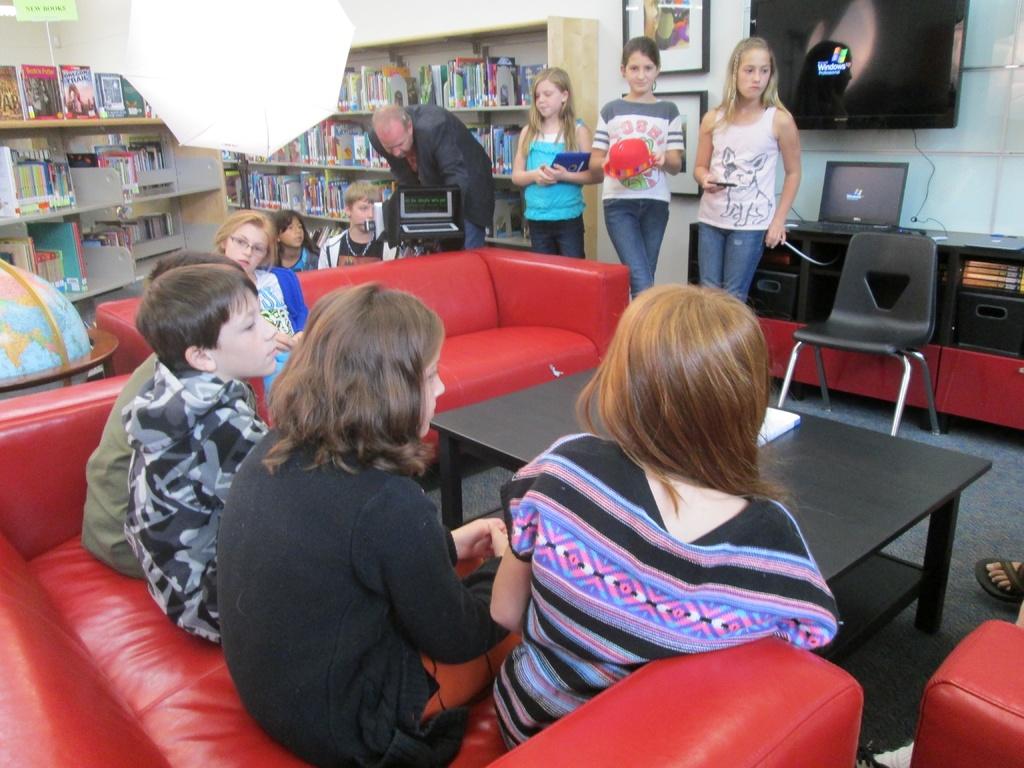What type of computers are they using?
Your answer should be compact. Windows. Is any text visible on the background books?
Your answer should be compact. No. 